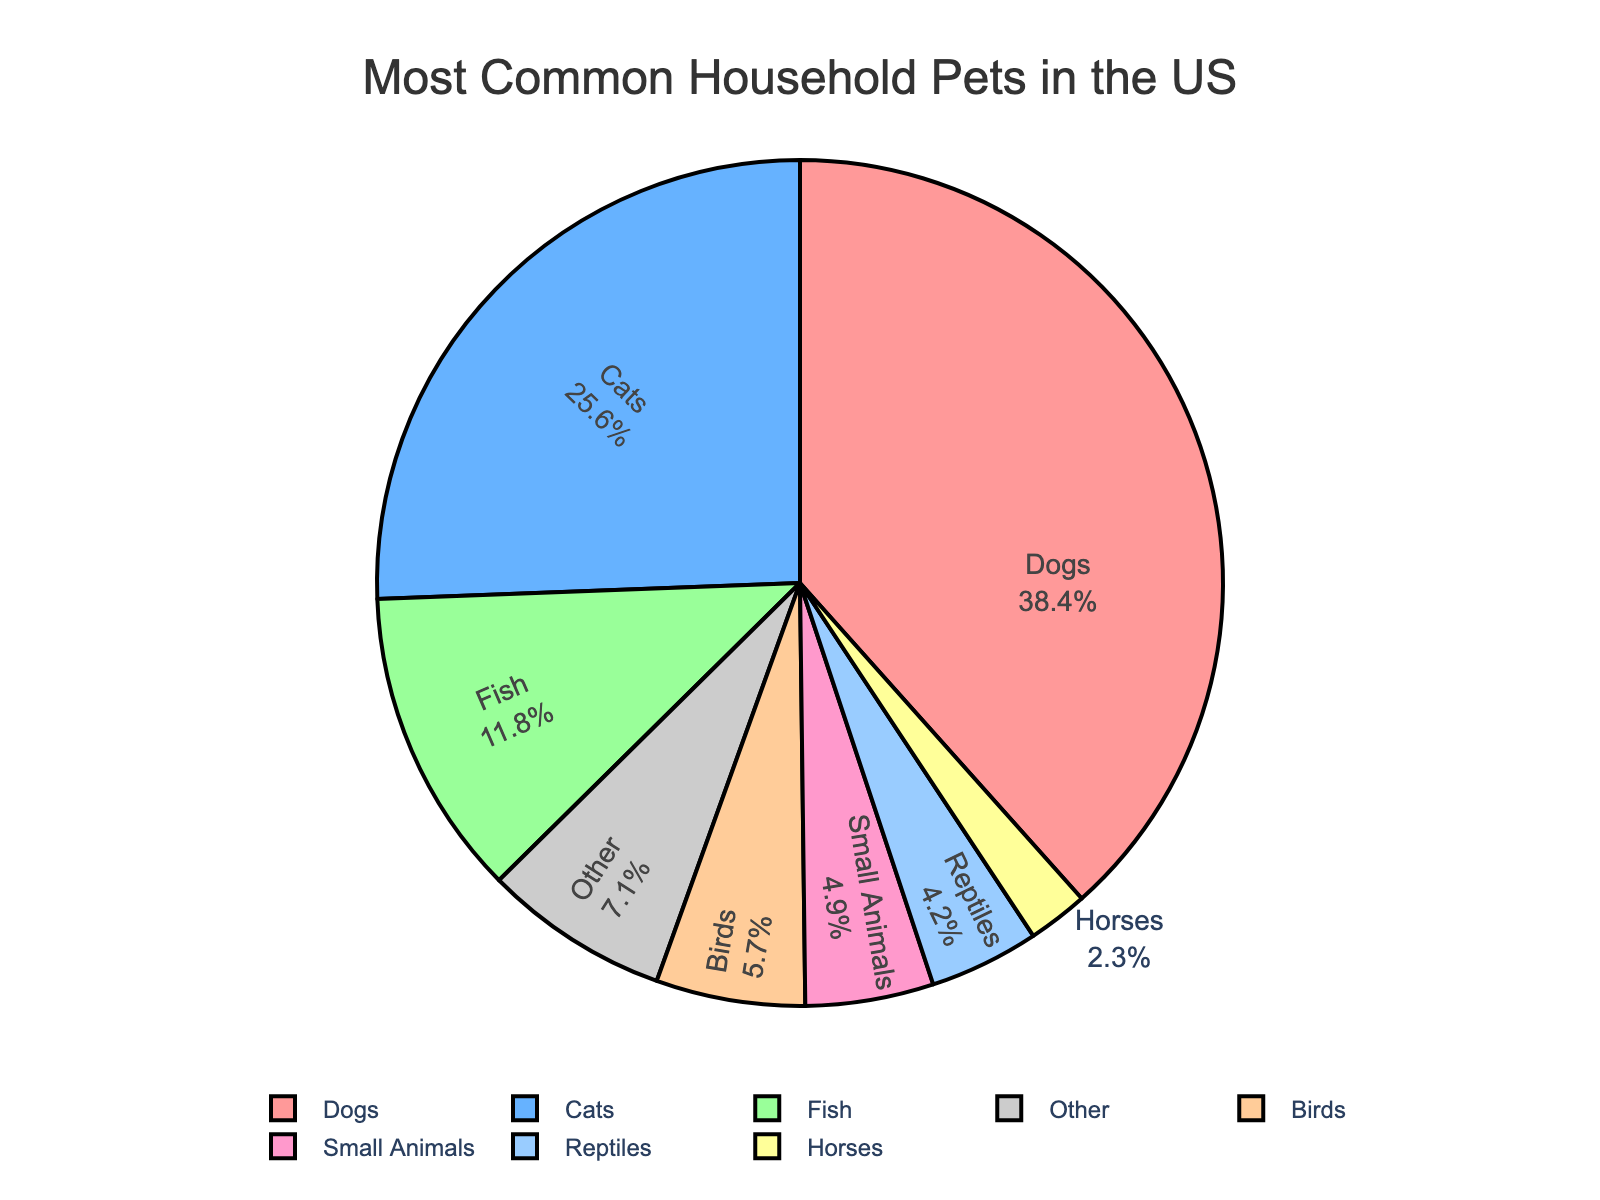What is the most common household pet in the US? According to the pie chart, the segment for "Dogs" is the largest, indicating it has the highest percentage. Therefore, dogs are the most common household pet in the US.
Answer: Dogs Which pet type has the smallest percentage? The smallest segment on the pie chart represents "Horses", indicating it has the smallest percentage.
Answer: Horses How much more popular are dogs compared to cats? Dogs have a percentage of 38.4%, while cats have 25.6%. Subtracting these values gives the difference: 38.4% - 25.6% = 12.8%.
Answer: 12.8% What percentage of households have pets other than dogs and cats? To find this, sum the percentages of all other pets: Fish (11.8) + Birds (5.7) + Small Animals (4.9) + Reptiles (4.2) + Horses (2.3) + Other (7.1) = 36.0%.
Answer: 36.0% Which are more common, reptiles or small animals? The segment for "Small Animals" is larger than that for "Reptiles". Thus, small animals are more common.
Answer: Small Animals Are there more households with fish or birds? The segment for "Fish" is larger than that for "Birds". Therefore, there are more households with fish.
Answer: Fish What is the combined percentage of households that have birds or reptiles? Add the percentages of households with birds (5.7%) and reptiles (4.2%): 5.7% + 4.2% = 9.9%.
Answer: 9.9% How many percentage points more popular are small animals compared to reptiles? Small animals have a percentage of 4.9%, while reptiles have 4.2%. Subtract these values to find the difference: 4.9% - 4.2% = 0.7%.
Answer: 0.7% Which pet types are less common than fish? The types with smaller segments than fish (11.8%) are birds (5.7%), small animals (4.9%), reptiles (4.2%), and horses (2.3%).
Answer: Birds, Small Animals, Reptiles, Horses What is the total percentage of households that have either dogs or cats? Add the percentages for dogs (38.4%) and cats (25.6%): 38.4% + 25.6% = 64.0%.
Answer: 64.0% 